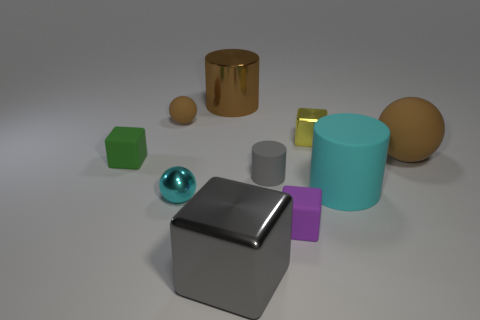Subtract all yellow cubes. How many cubes are left? 3 Subtract all yellow blocks. How many brown balls are left? 2 Subtract 2 cylinders. How many cylinders are left? 1 Subtract all yellow blocks. How many blocks are left? 3 Subtract all gray balls. Subtract all purple cylinders. How many balls are left? 3 Subtract all big red cubes. Subtract all cyan metallic objects. How many objects are left? 9 Add 2 large blocks. How many large blocks are left? 3 Add 9 tiny matte cylinders. How many tiny matte cylinders exist? 10 Subtract 1 green cubes. How many objects are left? 9 Subtract all blocks. How many objects are left? 6 